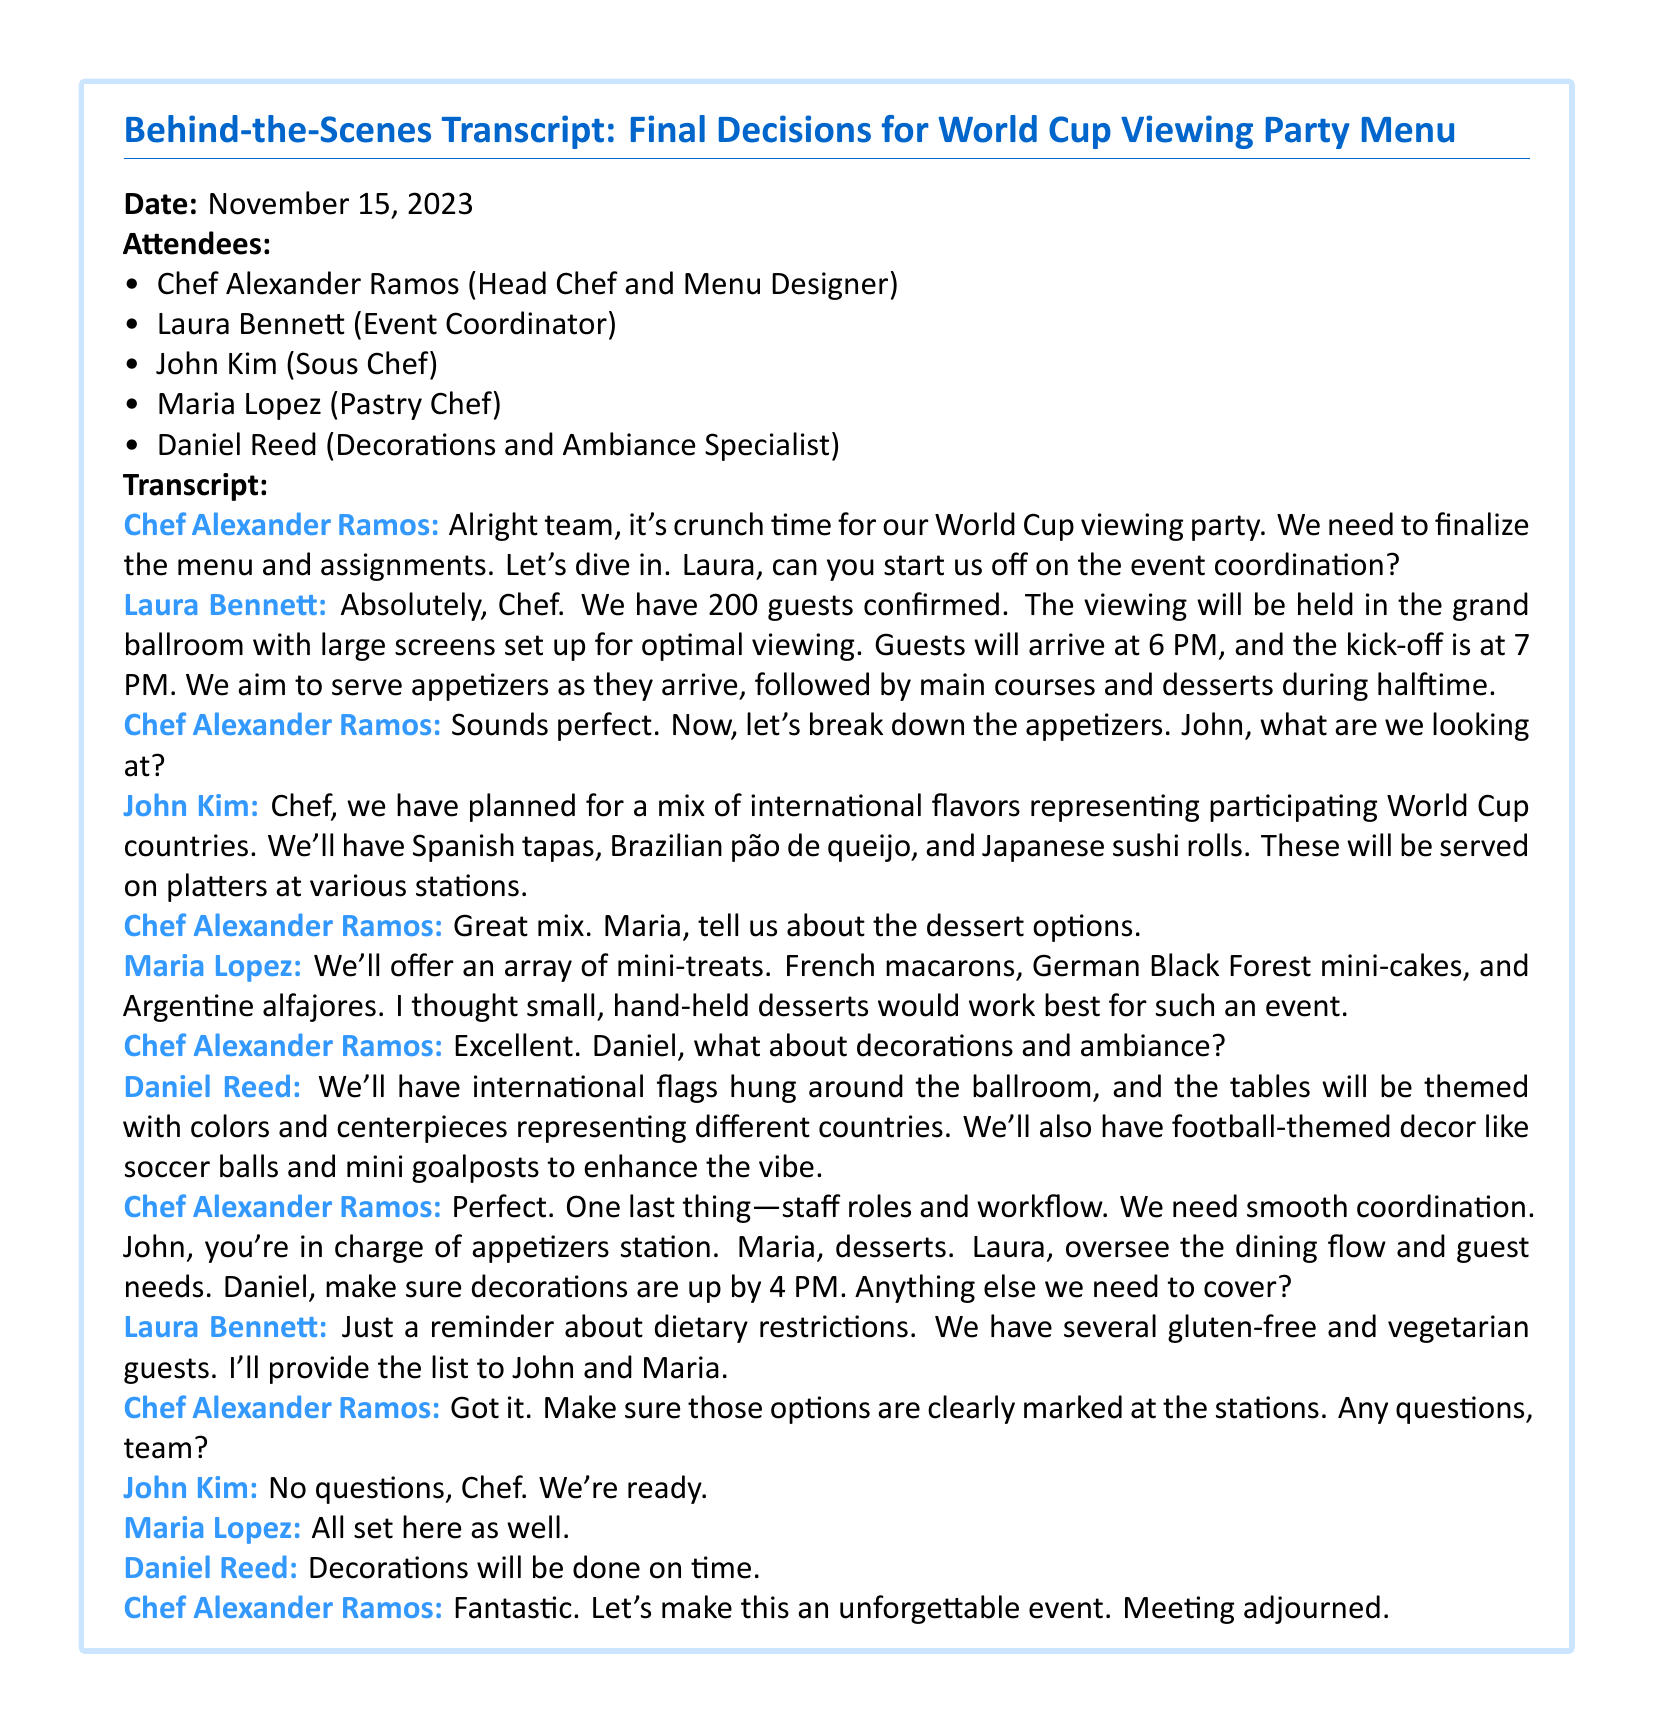what is the date of the meeting? The date of the meeting is clearly mentioned at the beginning of the transcript.
Answer: November 15, 2023 who is the Head Chef and Menu Designer? The document lists the attendees, highlighting the roles of each person present at the meeting.
Answer: Chef Alexander Ramos how many guests are confirmed for the event? The transcript includes information provided by the Event Coordinator about the number of guests.
Answer: 200 guests what type of dessert will be offered? The Pastry Chef describes the dessert options in the meeting, focusing on the types of desserts planned.
Answer: mini-treats who is responsible for overseeing dining flow and guest needs? The speaker corresponds to the Event Coordinator's role during the meeting, as mentioned in the distribution of staff roles.
Answer: Laura what stations are John and Maria in charge of? The assigned roles for appetizers and desserts are specified in the staff role distribution.
Answer: appetizers station and desserts what themed decor will be used in the ballroom? The Decorations and Ambiance Specialist details the visual elements planned for the event, including specific items mentioned.
Answer: international flags and football-themed decor what dietary restrictions did Laura mention? Laura reminds the team about specific guest dietary needs in the context of the event preparation.
Answer: gluten-free and vegetarian 